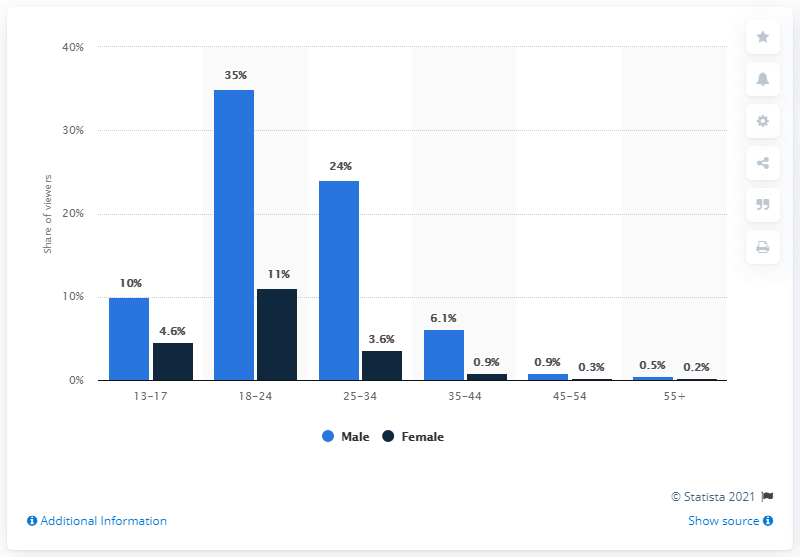Identify some key points in this picture. During the Rio 2016 Olympics, women made up 11% of the total number of viewers. 